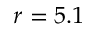<formula> <loc_0><loc_0><loc_500><loc_500>r = 5 . 1</formula> 